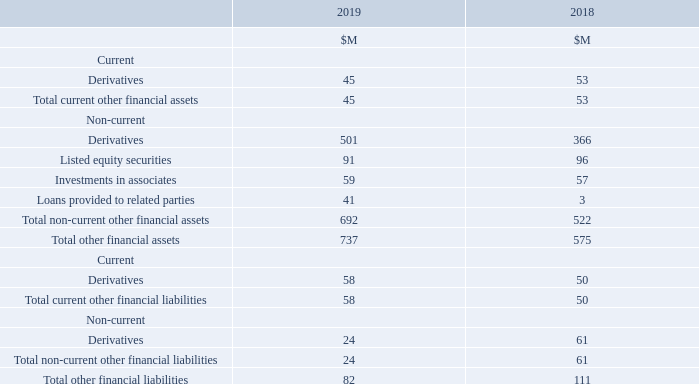Other financial assets and liabilities consists of derivatives, the Group’s holdings in listed and unlisted investments, and loans provided to related parties.
The Group’s investments in listed equity securities are designated as financial assets at fair value through other comprehensive income. Investments are initially measured at fair value net of transaction costs and, in subsequent periods, are measured at fair value with any change recognised in other comprehensive income. Upon disposal, the cumulative gain or loss recognised in other comprehensive income is transferred to retained earnings.
Associates are those entities in which the Group has significant influence but not control or joint control over the financial and operating policies. Investments in associates are initially recognised at cost including transaction costs and are accounted for using the equity method by including the Group’s share of profit or loss and other comprehensive income of associates in the carrying amount of the investment until the date on which significant influence ceases. Dividends received reduce the carrying amount of the investment in associates.
What is the total other financial assets in 2019?
Answer scale should be: million. 737. What are associates? Associates are those entities in which the group has significant influence but not control or joint control over the financial and operating policies. What is the unit used in the table? $m. What is the increase in total other financial assets from 2018 to 2019?
Answer scale should be: million. 737 - 575 
Answer: 162. What is the percentage constitution of current derivatives in the total other financial liabilities in 2019?
Answer scale should be: percent. 58 / 82 
Answer: 70.73. What is the average of the total other financial liabilities for both 2018 and 2019?
Answer scale should be: million. (82 + 111)/2 
Answer: 96.5. 